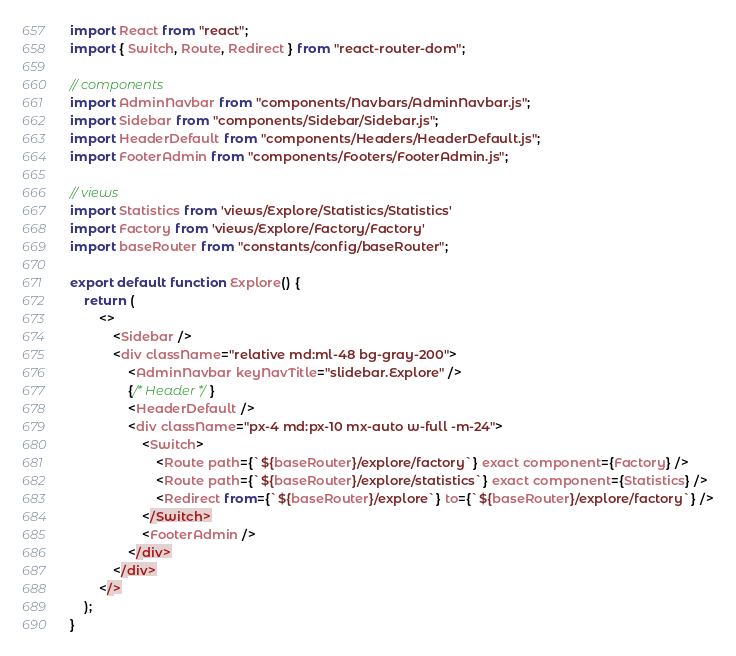<code> <loc_0><loc_0><loc_500><loc_500><_JavaScript_>import React from "react";
import { Switch, Route, Redirect } from "react-router-dom";

// components
import AdminNavbar from "components/Navbars/AdminNavbar.js";
import Sidebar from "components/Sidebar/Sidebar.js";
import HeaderDefault from "components/Headers/HeaderDefault.js";
import FooterAdmin from "components/Footers/FooterAdmin.js";

// views
import Statistics from 'views/Explore/Statistics/Statistics'
import Factory from 'views/Explore/Factory/Factory'
import baseRouter from "constants/config/baseRouter";

export default function Explore() {
    return (
        <>
            <Sidebar />
            <div className="relative md:ml-48 bg-gray-200">
                <AdminNavbar keyNavTitle="slidebar.Explore" />
                {/* Header */}
                <HeaderDefault />
                <div className="px-4 md:px-10 mx-auto w-full -m-24">
                    <Switch>
                        <Route path={`${baseRouter}/explore/factory`} exact component={Factory} />
                        <Route path={`${baseRouter}/explore/statistics`} exact component={Statistics} />
                        <Redirect from={`${baseRouter}/explore`} to={`${baseRouter}/explore/factory`} />
                    </Switch>
                    <FooterAdmin />
                </div>
            </div>
        </>
    );
}
</code> 